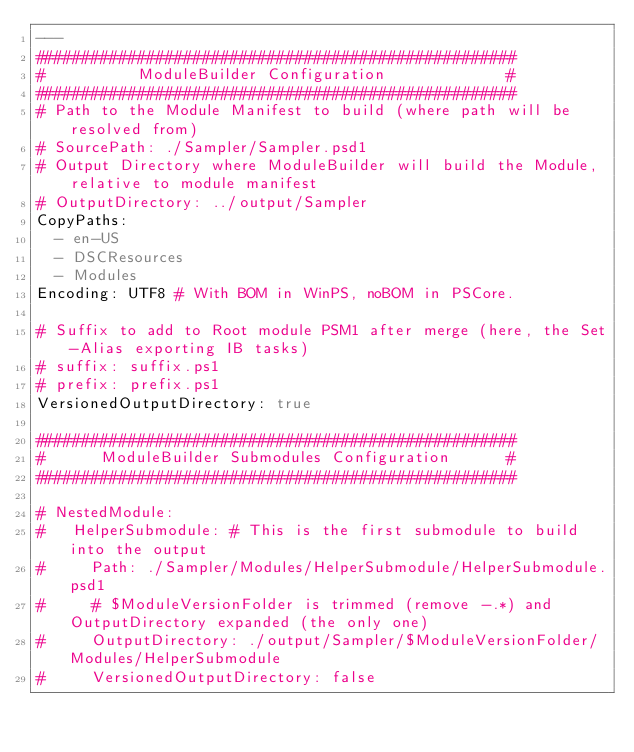Convert code to text. <code><loc_0><loc_0><loc_500><loc_500><_YAML_>---
####################################################
#          ModuleBuilder Configuration             #
####################################################
# Path to the Module Manifest to build (where path will be resolved from)
# SourcePath: ./Sampler/Sampler.psd1
# Output Directory where ModuleBuilder will build the Module, relative to module manifest
# OutputDirectory: ../output/Sampler
CopyPaths:
  - en-US
  - DSCResources
  - Modules
Encoding: UTF8 # With BOM in WinPS, noBOM in PSCore.

# Suffix to add to Root module PSM1 after merge (here, the Set-Alias exporting IB tasks)
# suffix: suffix.ps1
# prefix: prefix.ps1
VersionedOutputDirectory: true

####################################################
#      ModuleBuilder Submodules Configuration      #
####################################################

# NestedModule:
#   HelperSubmodule: # This is the first submodule to build into the output
#     Path: ./Sampler/Modules/HelperSubmodule/HelperSubmodule.psd1
#     # $ModuleVersionFolder is trimmed (remove -.*) and OutputDirectory expanded (the only one)
#     OutputDirectory: ./output/Sampler/$ModuleVersionFolder/Modules/HelperSubmodule
#     VersionedOutputDirectory: false</code> 